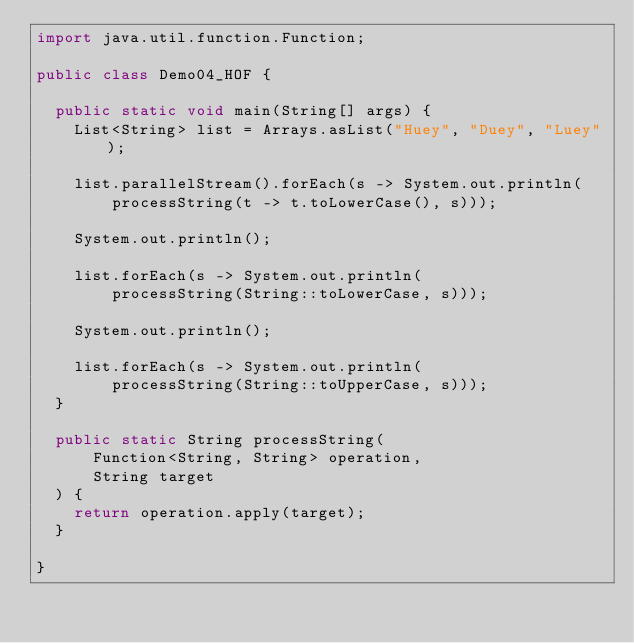Convert code to text. <code><loc_0><loc_0><loc_500><loc_500><_Java_>import java.util.function.Function;

public class Demo04_HOF {

	public static void main(String[] args) {
		List<String> list = Arrays.asList("Huey", "Duey", "Luey");
		
		list.parallelStream().forEach(s -> System.out.println(
				processString(t -> t.toLowerCase(), s)));
		
		System.out.println();
		
		list.forEach(s -> System.out.println(
				processString(String::toLowerCase, s)));
		
		System.out.println();
		
		list.forEach(s -> System.out.println(
				processString(String::toUpperCase, s)));
	}

	public static String processString(
			Function<String, String> operation, 
			String target
	) {
		return operation.apply(target);
	}
	
}
</code> 